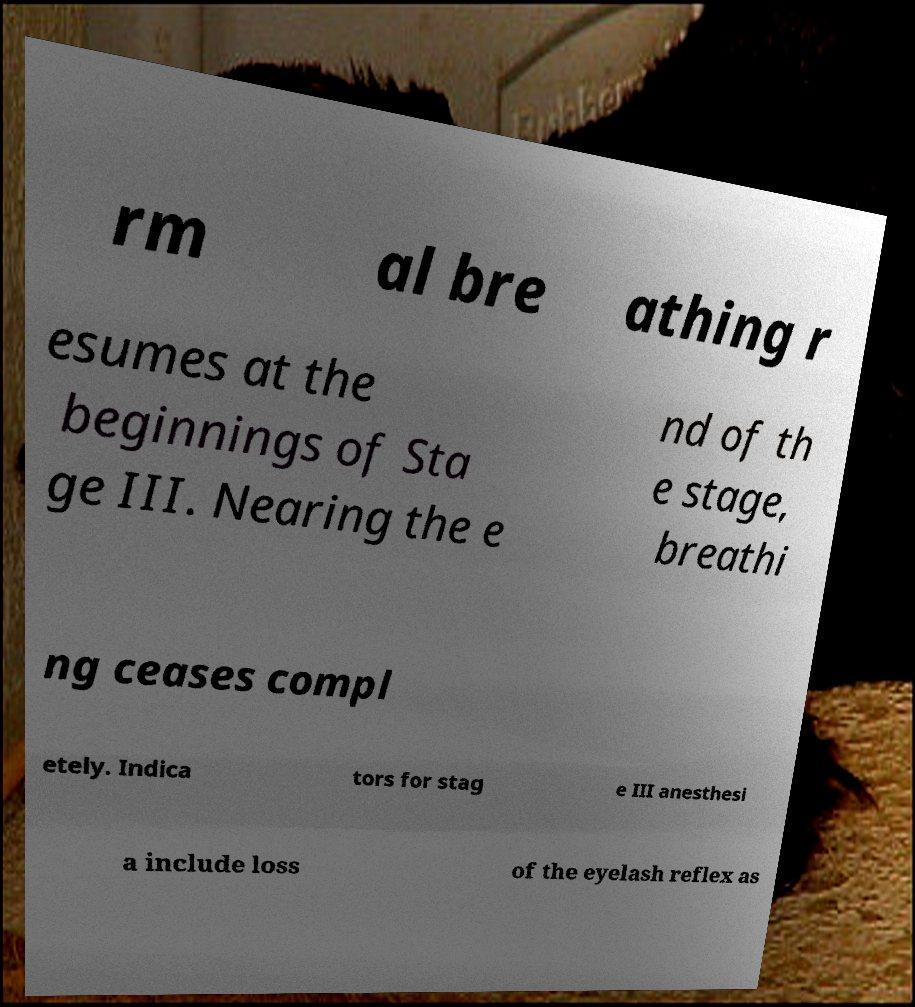Please read and relay the text visible in this image. What does it say? rm al bre athing r esumes at the beginnings of Sta ge III. Nearing the e nd of th e stage, breathi ng ceases compl etely. Indica tors for stag e III anesthesi a include loss of the eyelash reflex as 